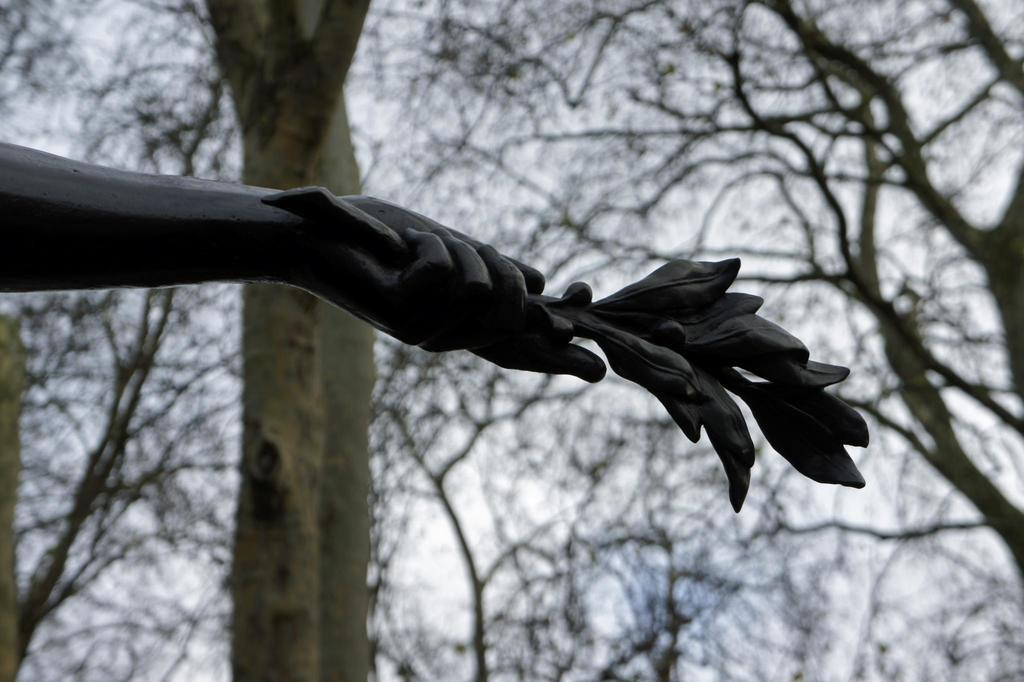What is the main subject in the image? There is a statue in the image. What is the statue doing with its hand? The statue's hand is holding an object. What can be seen in the background of the image? There are trees and the sky visible in the background of the image. How many attempts did the statue make to sleep in the image? There is no indication in the image that the statue is attempting to sleep, as it is a statue and not a living being. 